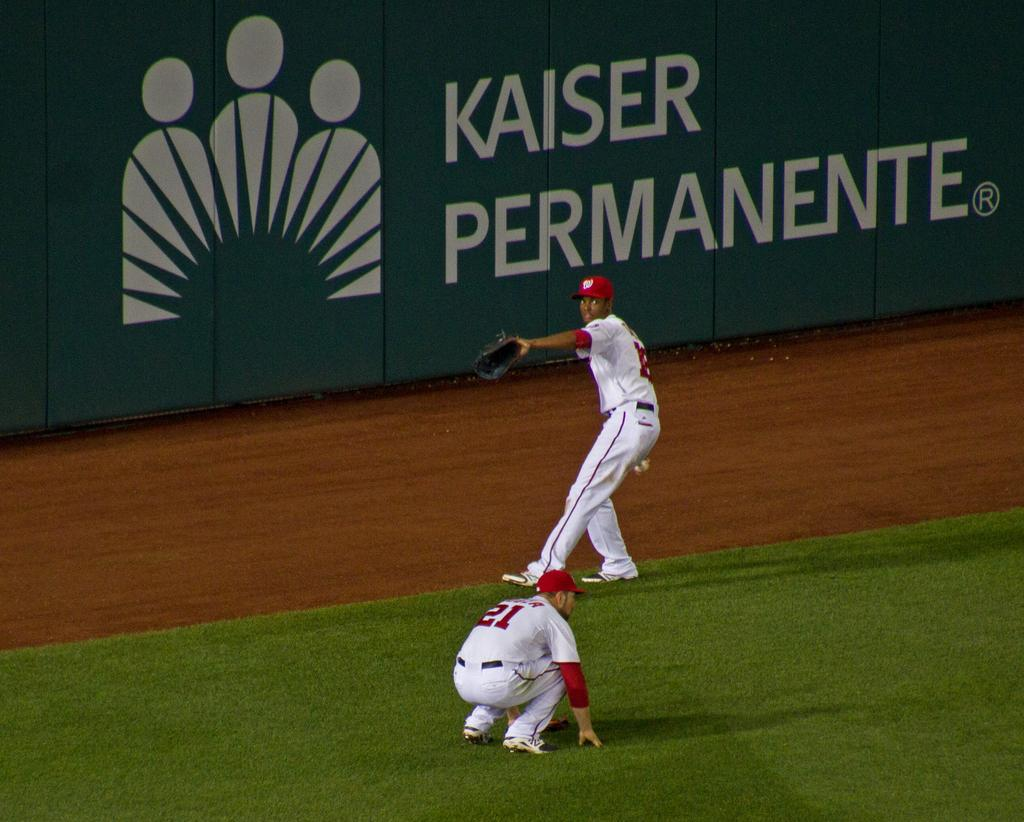<image>
Provide a brief description of the given image. Two baseball players in the outfield, one of them is preparing to throw the baseball, Kaiser Permanete ad in the back wall. 